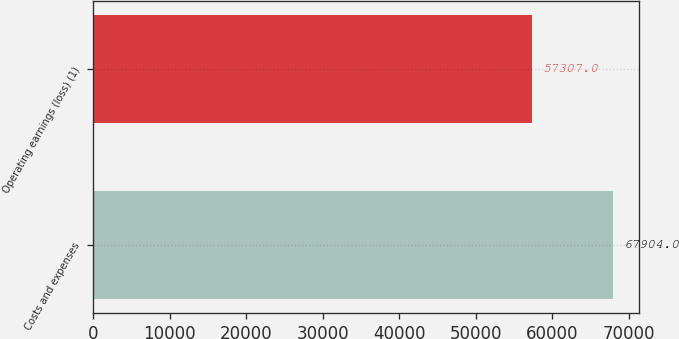Convert chart. <chart><loc_0><loc_0><loc_500><loc_500><bar_chart><fcel>Costs and expenses<fcel>Operating earnings (loss) (1)<nl><fcel>67904<fcel>57307<nl></chart> 